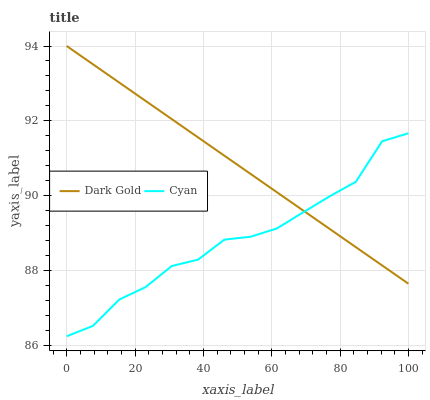Does Cyan have the minimum area under the curve?
Answer yes or no. Yes. Does Dark Gold have the maximum area under the curve?
Answer yes or no. Yes. Does Dark Gold have the minimum area under the curve?
Answer yes or no. No. Is Dark Gold the smoothest?
Answer yes or no. Yes. Is Cyan the roughest?
Answer yes or no. Yes. Is Dark Gold the roughest?
Answer yes or no. No. Does Cyan have the lowest value?
Answer yes or no. Yes. Does Dark Gold have the lowest value?
Answer yes or no. No. Does Dark Gold have the highest value?
Answer yes or no. Yes. Does Cyan intersect Dark Gold?
Answer yes or no. Yes. Is Cyan less than Dark Gold?
Answer yes or no. No. Is Cyan greater than Dark Gold?
Answer yes or no. No. 